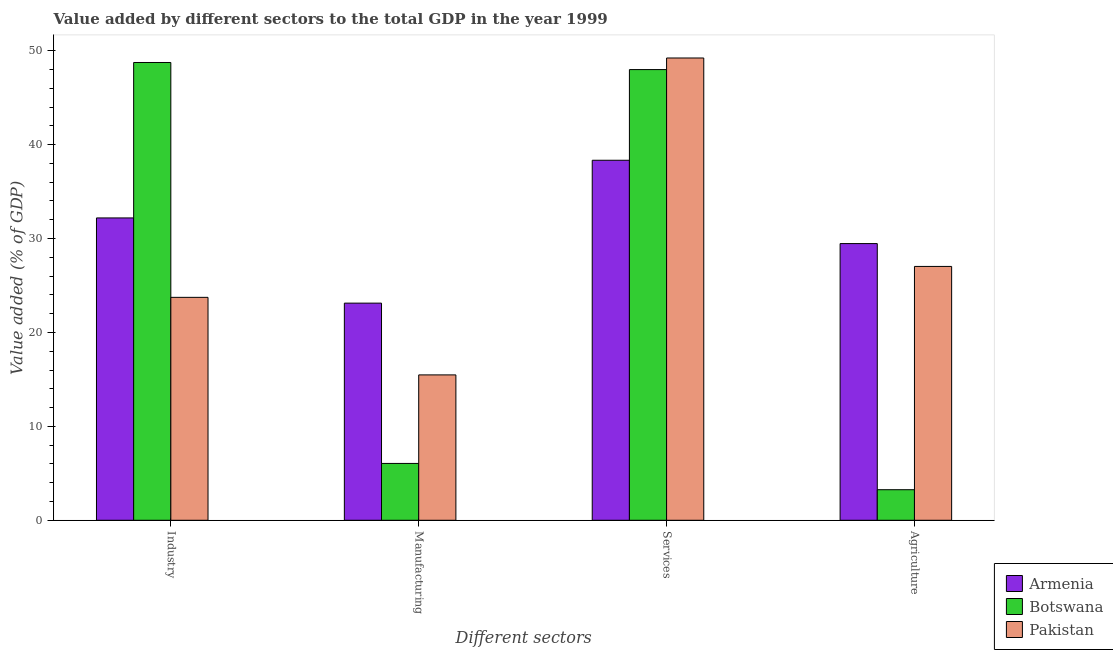Are the number of bars per tick equal to the number of legend labels?
Your response must be concise. Yes. What is the label of the 3rd group of bars from the left?
Your answer should be very brief. Services. What is the value added by industrial sector in Botswana?
Provide a short and direct response. 48.75. Across all countries, what is the maximum value added by agricultural sector?
Offer a terse response. 29.46. Across all countries, what is the minimum value added by manufacturing sector?
Give a very brief answer. 6.05. In which country was the value added by services sector maximum?
Your response must be concise. Pakistan. What is the total value added by agricultural sector in the graph?
Provide a succinct answer. 59.75. What is the difference between the value added by manufacturing sector in Armenia and that in Botswana?
Offer a terse response. 17.07. What is the difference between the value added by industrial sector in Armenia and the value added by agricultural sector in Pakistan?
Offer a terse response. 5.17. What is the average value added by industrial sector per country?
Provide a succinct answer. 34.9. What is the difference between the value added by services sector and value added by manufacturing sector in Armenia?
Your response must be concise. 15.22. What is the ratio of the value added by industrial sector in Armenia to that in Pakistan?
Give a very brief answer. 1.36. What is the difference between the highest and the second highest value added by industrial sector?
Your answer should be very brief. 16.55. What is the difference between the highest and the lowest value added by industrial sector?
Provide a short and direct response. 25.01. Is the sum of the value added by agricultural sector in Botswana and Armenia greater than the maximum value added by manufacturing sector across all countries?
Offer a terse response. Yes. Is it the case that in every country, the sum of the value added by services sector and value added by agricultural sector is greater than the sum of value added by industrial sector and value added by manufacturing sector?
Provide a short and direct response. Yes. What does the 2nd bar from the left in Industry represents?
Keep it short and to the point. Botswana. What does the 3rd bar from the right in Agriculture represents?
Offer a terse response. Armenia. How many bars are there?
Your response must be concise. 12. What is the difference between two consecutive major ticks on the Y-axis?
Your answer should be very brief. 10. Does the graph contain any zero values?
Offer a terse response. No. Does the graph contain grids?
Your response must be concise. No. How many legend labels are there?
Make the answer very short. 3. What is the title of the graph?
Ensure brevity in your answer.  Value added by different sectors to the total GDP in the year 1999. What is the label or title of the X-axis?
Your response must be concise. Different sectors. What is the label or title of the Y-axis?
Your answer should be very brief. Value added (% of GDP). What is the Value added (% of GDP) of Armenia in Industry?
Provide a short and direct response. 32.2. What is the Value added (% of GDP) of Botswana in Industry?
Keep it short and to the point. 48.75. What is the Value added (% of GDP) of Pakistan in Industry?
Provide a short and direct response. 23.74. What is the Value added (% of GDP) of Armenia in Manufacturing?
Ensure brevity in your answer.  23.12. What is the Value added (% of GDP) of Botswana in Manufacturing?
Give a very brief answer. 6.05. What is the Value added (% of GDP) in Pakistan in Manufacturing?
Provide a succinct answer. 15.48. What is the Value added (% of GDP) in Armenia in Services?
Make the answer very short. 38.34. What is the Value added (% of GDP) in Botswana in Services?
Your answer should be compact. 48. What is the Value added (% of GDP) in Pakistan in Services?
Make the answer very short. 49.23. What is the Value added (% of GDP) in Armenia in Agriculture?
Your response must be concise. 29.46. What is the Value added (% of GDP) of Botswana in Agriculture?
Keep it short and to the point. 3.25. What is the Value added (% of GDP) in Pakistan in Agriculture?
Your answer should be compact. 27.03. Across all Different sectors, what is the maximum Value added (% of GDP) in Armenia?
Offer a terse response. 38.34. Across all Different sectors, what is the maximum Value added (% of GDP) of Botswana?
Make the answer very short. 48.75. Across all Different sectors, what is the maximum Value added (% of GDP) in Pakistan?
Provide a short and direct response. 49.23. Across all Different sectors, what is the minimum Value added (% of GDP) in Armenia?
Your response must be concise. 23.12. Across all Different sectors, what is the minimum Value added (% of GDP) in Botswana?
Your answer should be very brief. 3.25. Across all Different sectors, what is the minimum Value added (% of GDP) in Pakistan?
Your answer should be very brief. 15.48. What is the total Value added (% of GDP) of Armenia in the graph?
Provide a short and direct response. 123.12. What is the total Value added (% of GDP) in Botswana in the graph?
Your response must be concise. 106.05. What is the total Value added (% of GDP) of Pakistan in the graph?
Your answer should be compact. 115.48. What is the difference between the Value added (% of GDP) in Armenia in Industry and that in Manufacturing?
Ensure brevity in your answer.  9.07. What is the difference between the Value added (% of GDP) of Botswana in Industry and that in Manufacturing?
Your answer should be very brief. 42.7. What is the difference between the Value added (% of GDP) in Pakistan in Industry and that in Manufacturing?
Give a very brief answer. 8.26. What is the difference between the Value added (% of GDP) in Armenia in Industry and that in Services?
Keep it short and to the point. -6.14. What is the difference between the Value added (% of GDP) in Botswana in Industry and that in Services?
Ensure brevity in your answer.  0.75. What is the difference between the Value added (% of GDP) in Pakistan in Industry and that in Services?
Offer a terse response. -25.49. What is the difference between the Value added (% of GDP) in Armenia in Industry and that in Agriculture?
Your answer should be compact. 2.73. What is the difference between the Value added (% of GDP) of Botswana in Industry and that in Agriculture?
Your answer should be compact. 45.5. What is the difference between the Value added (% of GDP) in Pakistan in Industry and that in Agriculture?
Keep it short and to the point. -3.29. What is the difference between the Value added (% of GDP) of Armenia in Manufacturing and that in Services?
Your answer should be very brief. -15.22. What is the difference between the Value added (% of GDP) in Botswana in Manufacturing and that in Services?
Provide a short and direct response. -41.94. What is the difference between the Value added (% of GDP) of Pakistan in Manufacturing and that in Services?
Keep it short and to the point. -33.75. What is the difference between the Value added (% of GDP) of Armenia in Manufacturing and that in Agriculture?
Keep it short and to the point. -6.34. What is the difference between the Value added (% of GDP) of Botswana in Manufacturing and that in Agriculture?
Offer a very short reply. 2.8. What is the difference between the Value added (% of GDP) of Pakistan in Manufacturing and that in Agriculture?
Provide a succinct answer. -11.55. What is the difference between the Value added (% of GDP) in Armenia in Services and that in Agriculture?
Offer a terse response. 8.88. What is the difference between the Value added (% of GDP) of Botswana in Services and that in Agriculture?
Your answer should be compact. 44.74. What is the difference between the Value added (% of GDP) of Pakistan in Services and that in Agriculture?
Provide a short and direct response. 22.2. What is the difference between the Value added (% of GDP) of Armenia in Industry and the Value added (% of GDP) of Botswana in Manufacturing?
Keep it short and to the point. 26.14. What is the difference between the Value added (% of GDP) of Armenia in Industry and the Value added (% of GDP) of Pakistan in Manufacturing?
Your answer should be very brief. 16.72. What is the difference between the Value added (% of GDP) in Botswana in Industry and the Value added (% of GDP) in Pakistan in Manufacturing?
Make the answer very short. 33.27. What is the difference between the Value added (% of GDP) in Armenia in Industry and the Value added (% of GDP) in Botswana in Services?
Offer a very short reply. -15.8. What is the difference between the Value added (% of GDP) in Armenia in Industry and the Value added (% of GDP) in Pakistan in Services?
Ensure brevity in your answer.  -17.03. What is the difference between the Value added (% of GDP) in Botswana in Industry and the Value added (% of GDP) in Pakistan in Services?
Ensure brevity in your answer.  -0.48. What is the difference between the Value added (% of GDP) in Armenia in Industry and the Value added (% of GDP) in Botswana in Agriculture?
Your response must be concise. 28.94. What is the difference between the Value added (% of GDP) of Armenia in Industry and the Value added (% of GDP) of Pakistan in Agriculture?
Offer a terse response. 5.17. What is the difference between the Value added (% of GDP) in Botswana in Industry and the Value added (% of GDP) in Pakistan in Agriculture?
Your answer should be compact. 21.72. What is the difference between the Value added (% of GDP) in Armenia in Manufacturing and the Value added (% of GDP) in Botswana in Services?
Offer a terse response. -24.87. What is the difference between the Value added (% of GDP) in Armenia in Manufacturing and the Value added (% of GDP) in Pakistan in Services?
Offer a terse response. -26.11. What is the difference between the Value added (% of GDP) of Botswana in Manufacturing and the Value added (% of GDP) of Pakistan in Services?
Provide a succinct answer. -43.18. What is the difference between the Value added (% of GDP) in Armenia in Manufacturing and the Value added (% of GDP) in Botswana in Agriculture?
Your answer should be compact. 19.87. What is the difference between the Value added (% of GDP) in Armenia in Manufacturing and the Value added (% of GDP) in Pakistan in Agriculture?
Your response must be concise. -3.91. What is the difference between the Value added (% of GDP) of Botswana in Manufacturing and the Value added (% of GDP) of Pakistan in Agriculture?
Provide a short and direct response. -20.98. What is the difference between the Value added (% of GDP) in Armenia in Services and the Value added (% of GDP) in Botswana in Agriculture?
Ensure brevity in your answer.  35.08. What is the difference between the Value added (% of GDP) of Armenia in Services and the Value added (% of GDP) of Pakistan in Agriculture?
Make the answer very short. 11.31. What is the difference between the Value added (% of GDP) of Botswana in Services and the Value added (% of GDP) of Pakistan in Agriculture?
Offer a terse response. 20.96. What is the average Value added (% of GDP) of Armenia per Different sectors?
Give a very brief answer. 30.78. What is the average Value added (% of GDP) of Botswana per Different sectors?
Offer a terse response. 26.51. What is the average Value added (% of GDP) of Pakistan per Different sectors?
Ensure brevity in your answer.  28.87. What is the difference between the Value added (% of GDP) in Armenia and Value added (% of GDP) in Botswana in Industry?
Your answer should be compact. -16.55. What is the difference between the Value added (% of GDP) in Armenia and Value added (% of GDP) in Pakistan in Industry?
Keep it short and to the point. 8.46. What is the difference between the Value added (% of GDP) in Botswana and Value added (% of GDP) in Pakistan in Industry?
Offer a terse response. 25.01. What is the difference between the Value added (% of GDP) in Armenia and Value added (% of GDP) in Botswana in Manufacturing?
Give a very brief answer. 17.07. What is the difference between the Value added (% of GDP) in Armenia and Value added (% of GDP) in Pakistan in Manufacturing?
Your answer should be very brief. 7.64. What is the difference between the Value added (% of GDP) in Botswana and Value added (% of GDP) in Pakistan in Manufacturing?
Make the answer very short. -9.43. What is the difference between the Value added (% of GDP) of Armenia and Value added (% of GDP) of Botswana in Services?
Your answer should be compact. -9.66. What is the difference between the Value added (% of GDP) in Armenia and Value added (% of GDP) in Pakistan in Services?
Make the answer very short. -10.89. What is the difference between the Value added (% of GDP) in Botswana and Value added (% of GDP) in Pakistan in Services?
Offer a terse response. -1.23. What is the difference between the Value added (% of GDP) of Armenia and Value added (% of GDP) of Botswana in Agriculture?
Offer a terse response. 26.21. What is the difference between the Value added (% of GDP) of Armenia and Value added (% of GDP) of Pakistan in Agriculture?
Offer a terse response. 2.43. What is the difference between the Value added (% of GDP) in Botswana and Value added (% of GDP) in Pakistan in Agriculture?
Offer a very short reply. -23.78. What is the ratio of the Value added (% of GDP) of Armenia in Industry to that in Manufacturing?
Provide a short and direct response. 1.39. What is the ratio of the Value added (% of GDP) in Botswana in Industry to that in Manufacturing?
Your response must be concise. 8.05. What is the ratio of the Value added (% of GDP) of Pakistan in Industry to that in Manufacturing?
Your answer should be very brief. 1.53. What is the ratio of the Value added (% of GDP) in Armenia in Industry to that in Services?
Ensure brevity in your answer.  0.84. What is the ratio of the Value added (% of GDP) in Botswana in Industry to that in Services?
Ensure brevity in your answer.  1.02. What is the ratio of the Value added (% of GDP) of Pakistan in Industry to that in Services?
Make the answer very short. 0.48. What is the ratio of the Value added (% of GDP) of Armenia in Industry to that in Agriculture?
Provide a succinct answer. 1.09. What is the ratio of the Value added (% of GDP) in Botswana in Industry to that in Agriculture?
Keep it short and to the point. 14.98. What is the ratio of the Value added (% of GDP) in Pakistan in Industry to that in Agriculture?
Keep it short and to the point. 0.88. What is the ratio of the Value added (% of GDP) of Armenia in Manufacturing to that in Services?
Your answer should be compact. 0.6. What is the ratio of the Value added (% of GDP) of Botswana in Manufacturing to that in Services?
Your response must be concise. 0.13. What is the ratio of the Value added (% of GDP) of Pakistan in Manufacturing to that in Services?
Provide a short and direct response. 0.31. What is the ratio of the Value added (% of GDP) in Armenia in Manufacturing to that in Agriculture?
Provide a succinct answer. 0.78. What is the ratio of the Value added (% of GDP) in Botswana in Manufacturing to that in Agriculture?
Ensure brevity in your answer.  1.86. What is the ratio of the Value added (% of GDP) in Pakistan in Manufacturing to that in Agriculture?
Your answer should be very brief. 0.57. What is the ratio of the Value added (% of GDP) in Armenia in Services to that in Agriculture?
Offer a very short reply. 1.3. What is the ratio of the Value added (% of GDP) in Botswana in Services to that in Agriculture?
Give a very brief answer. 14.75. What is the ratio of the Value added (% of GDP) in Pakistan in Services to that in Agriculture?
Make the answer very short. 1.82. What is the difference between the highest and the second highest Value added (% of GDP) of Armenia?
Your response must be concise. 6.14. What is the difference between the highest and the second highest Value added (% of GDP) in Botswana?
Your response must be concise. 0.75. What is the difference between the highest and the second highest Value added (% of GDP) in Pakistan?
Give a very brief answer. 22.2. What is the difference between the highest and the lowest Value added (% of GDP) in Armenia?
Provide a succinct answer. 15.22. What is the difference between the highest and the lowest Value added (% of GDP) of Botswana?
Ensure brevity in your answer.  45.5. What is the difference between the highest and the lowest Value added (% of GDP) of Pakistan?
Provide a succinct answer. 33.75. 